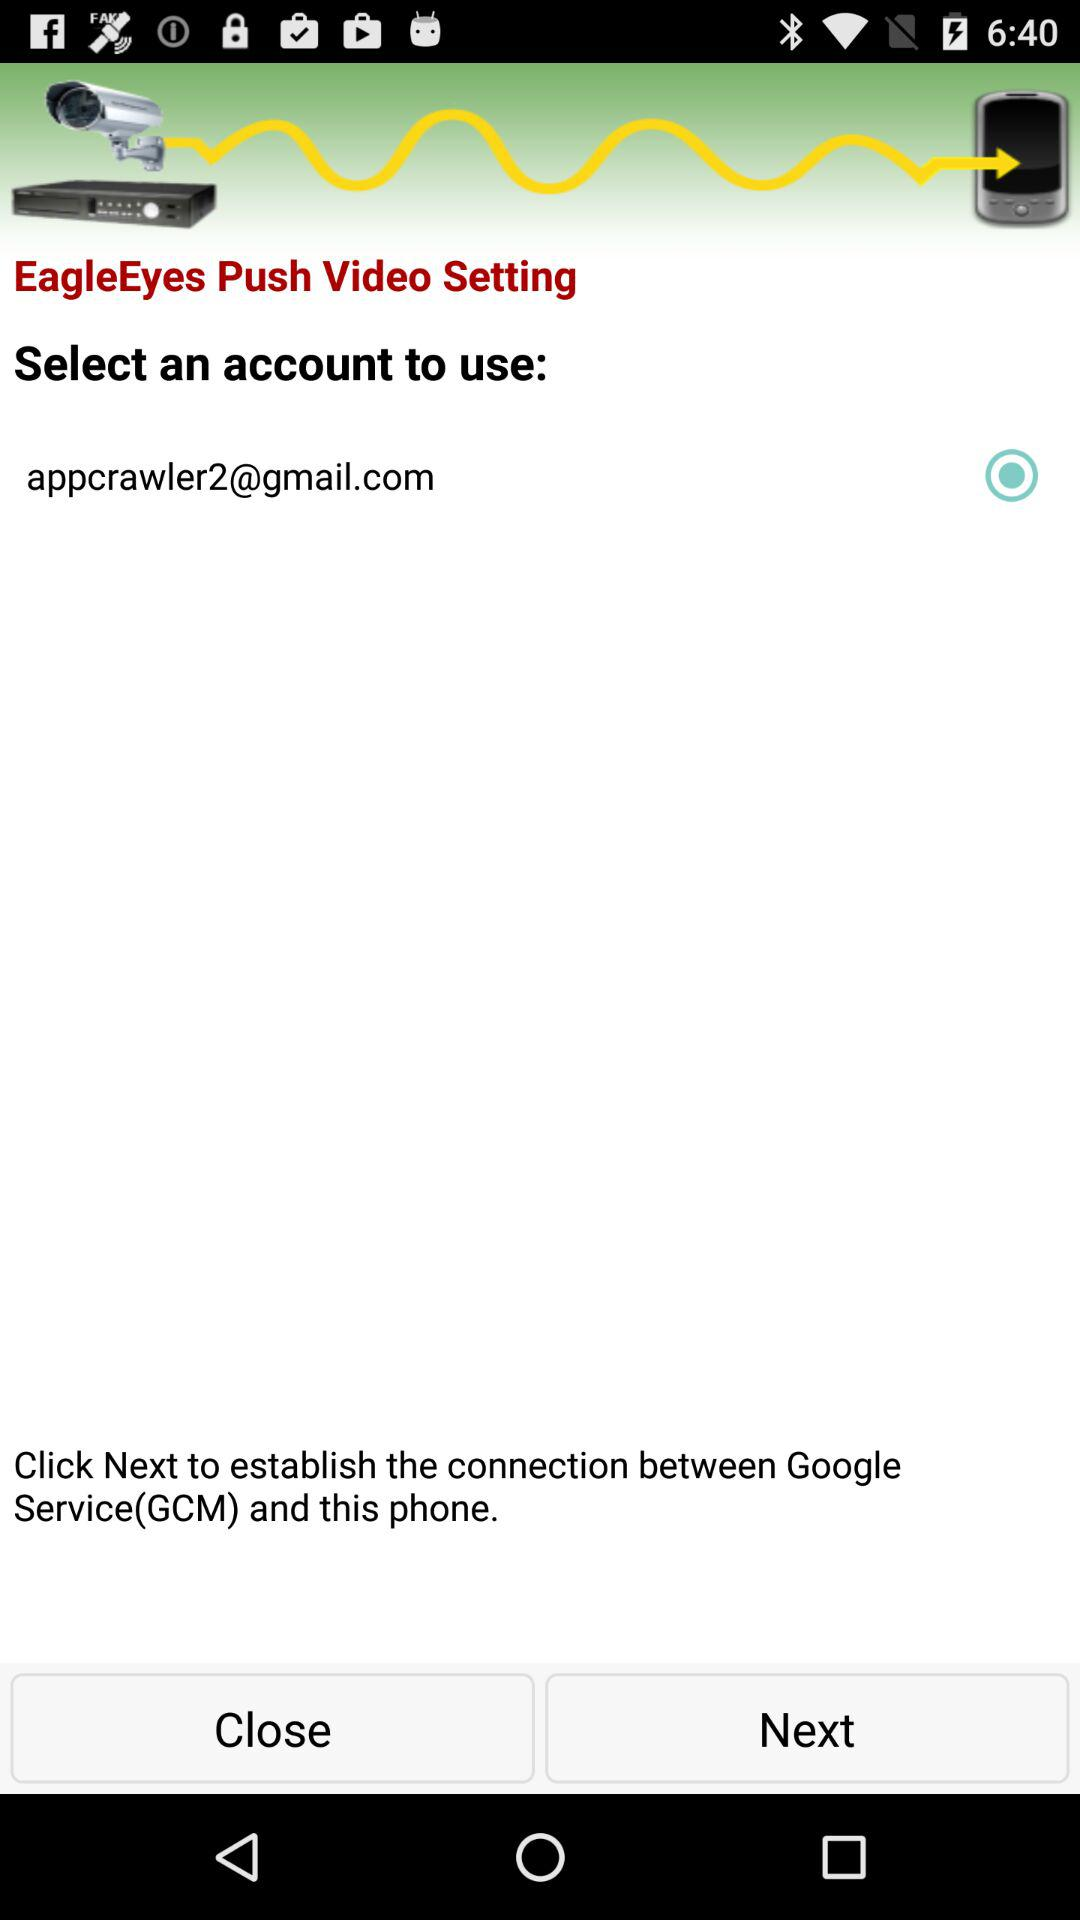What is the Gmail address? The Gmail address is appcrawler2@gmail.com. 